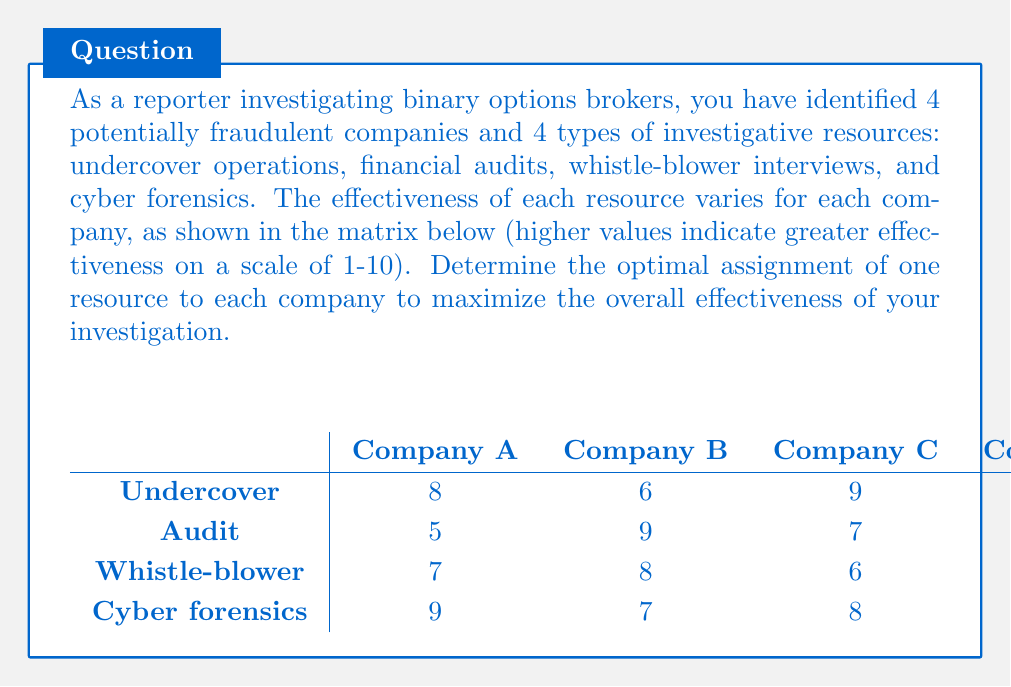Provide a solution to this math problem. To solve this assignment problem, we'll use the Hungarian algorithm:

1) First, subtract the smallest element in each row from every element in that row:

$$
\begin{array}{c|cccc}
 & \text{A} & \text{B} & \text{C} & \text{D} \\
\hline
\text{Undercover} & 2 & 0 & 3 & 1 \\
\text{Audit} & 0 & 4 & 2 & 3 \\
\text{Whistle-blower} & 2 & 3 & 1 & 0 \\
\text{Cyber forensics} & 3 & 1 & 2 & 0 \\
\end{array}
$$

2) Subtract the smallest element in each column from every element in that column:

$$
\begin{array}{c|cccc}
 & \text{A} & \text{B} & \text{C} & \text{D} \\
\hline
\text{Undercover} & 2 & 0 & 2 & 1 \\
\text{Audit} & 0 & 4 & 1 & 3 \\
\text{Whistle-blower} & 2 & 3 & 0 & 0 \\
\text{Cyber forensics} & 3 & 1 & 1 & 0 \\
\end{array}
$$

3) Draw lines through rows and columns to cover all zeros using the minimum number of lines:

$$
\begin{array}{c|cccc}
 & \text{A} & \text{B} & \text{C} & \text{D} \\
\hline
\text{Undercover} & 2 & \color{red}0 & 2 & 1 \\
\text{Audit} & \color{red}0 & 4 & 1 & 3 \\
\text{Whistle-blower} & 2 & 3 & \color{red}0 & \color{red}0 \\
\text{Cyber forensics} & 3 & 1 & 1 & \color{red}0 \\
\end{array}
$$

4) Since we need 4 lines to cover all zeros, we have an optimal solution. We can now make the assignments:

- Undercover to Company B
- Audit to Company A
- Whistle-blower to Company C
- Cyber forensics to Company D

5) To calculate the total effectiveness, we sum the original values for these assignments:

$6 + 5 + 6 + 6 = 23$

Therefore, the optimal assignment yields a total effectiveness score of 23.
Answer: The optimal assignment is:
- Undercover operations for Company B
- Financial audit for Company A
- Whistle-blower interview for Company C
- Cyber forensics for Company D

This assignment yields a total effectiveness score of 23. 